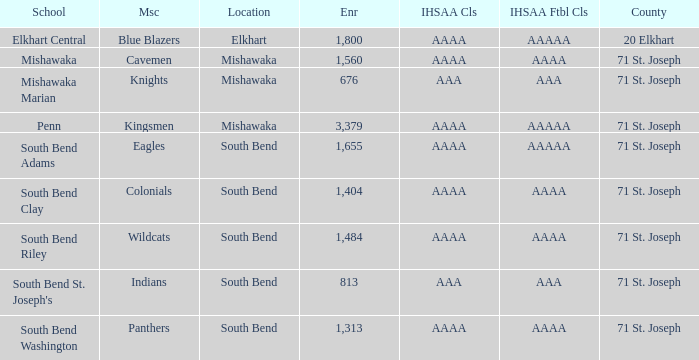What location has kingsmen as the mascot? Mishawaka. 